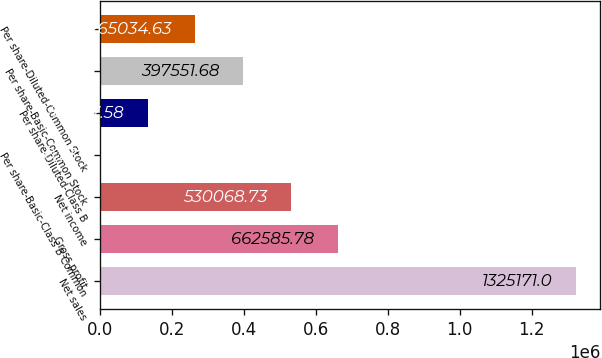Convert chart to OTSL. <chart><loc_0><loc_0><loc_500><loc_500><bar_chart><fcel>Net sales<fcel>Gross profit<fcel>Net income<fcel>Per share-Basic-Class B Common<fcel>Per share-Diluted-Class B<fcel>Per share-Basic-Common Stock<fcel>Per share-Diluted-Common Stock<nl><fcel>1.32517e+06<fcel>662586<fcel>530069<fcel>0.53<fcel>132518<fcel>397552<fcel>265035<nl></chart> 